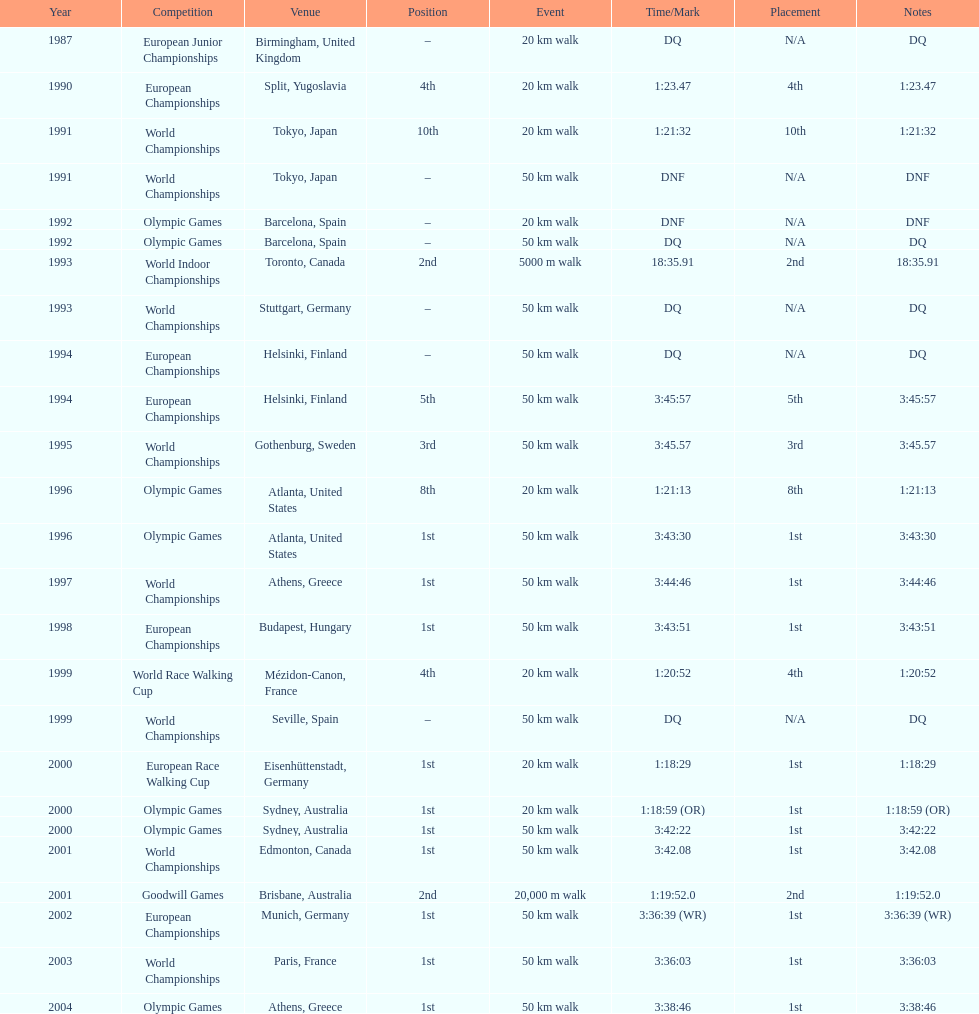What was the distinction in korzeniowski's performance during the 20 km walk event at the 1996 and 2000 olympic games? 2:14. 